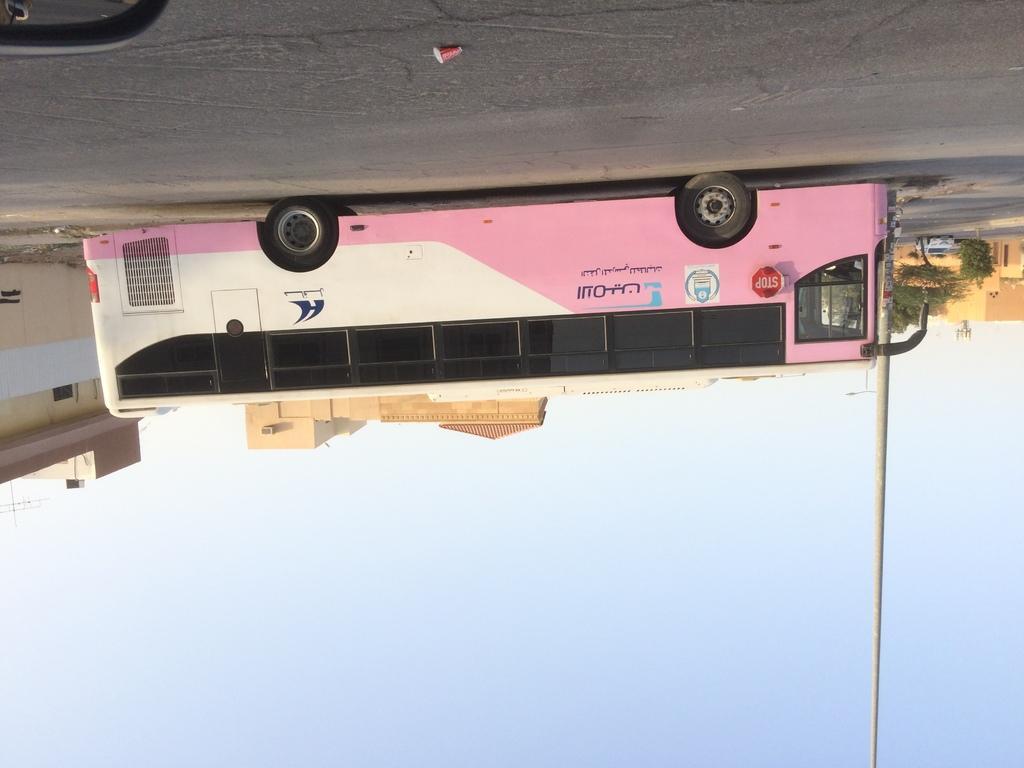Could you give a brief overview of what you see in this image? This is a reversed image, in this image at the bottom there is the sky and a pole, at the top there is a road, on that road there is a bus, behind the bus there are houses and trees. 